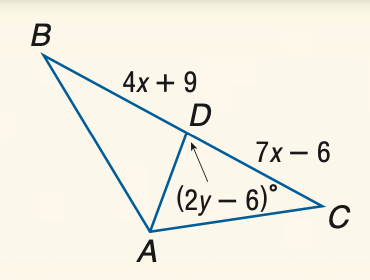Answer the mathemtical geometry problem and directly provide the correct option letter.
Question: Find y if A D is an altitude of \triangle A B C.
Choices: A: 42 B: 44 C: 46 D: 48 D 